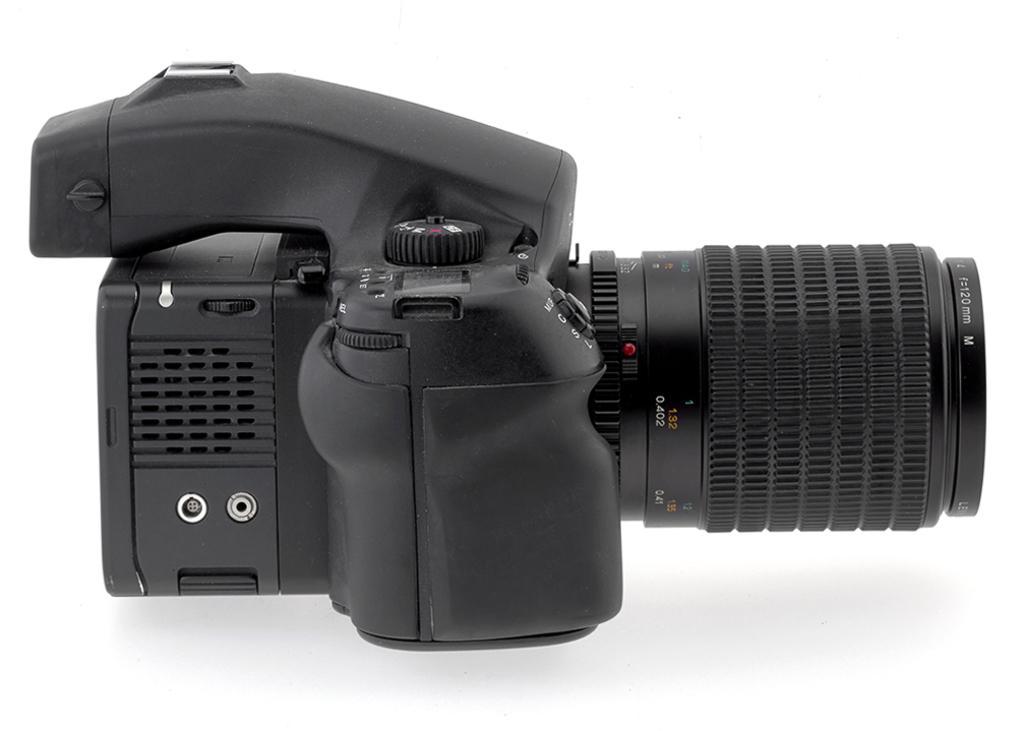Please provide a concise description of this image. In this image we can see a camera with lens placed on the surface. 